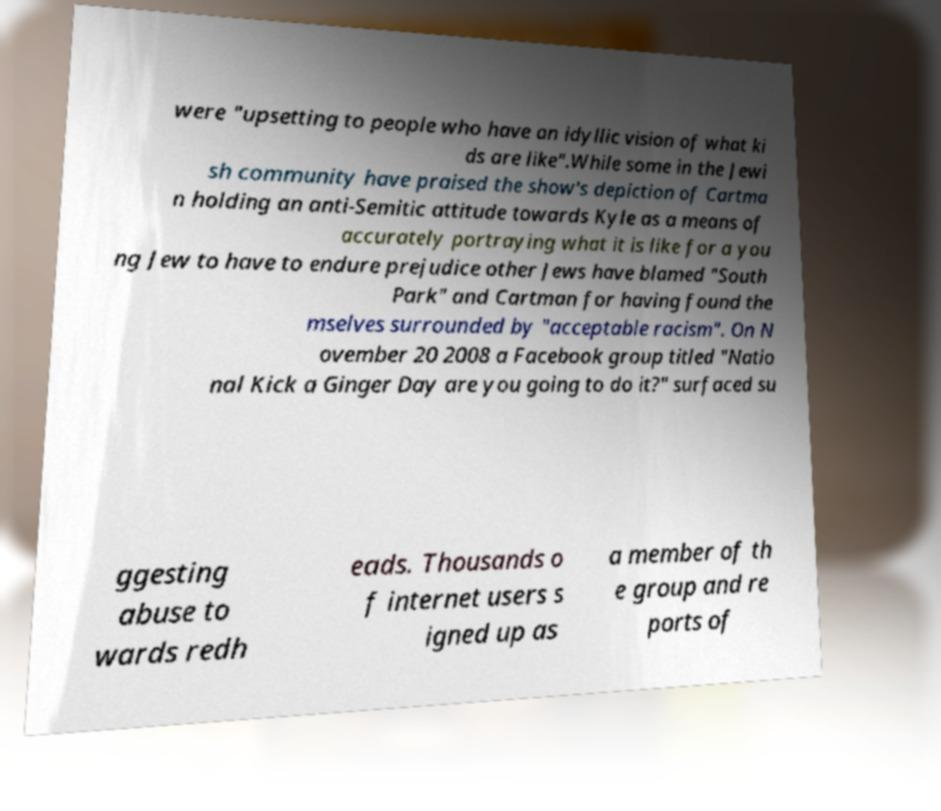There's text embedded in this image that I need extracted. Can you transcribe it verbatim? were "upsetting to people who have an idyllic vision of what ki ds are like".While some in the Jewi sh community have praised the show's depiction of Cartma n holding an anti-Semitic attitude towards Kyle as a means of accurately portraying what it is like for a you ng Jew to have to endure prejudice other Jews have blamed "South Park" and Cartman for having found the mselves surrounded by "acceptable racism". On N ovember 20 2008 a Facebook group titled "Natio nal Kick a Ginger Day are you going to do it?" surfaced su ggesting abuse to wards redh eads. Thousands o f internet users s igned up as a member of th e group and re ports of 